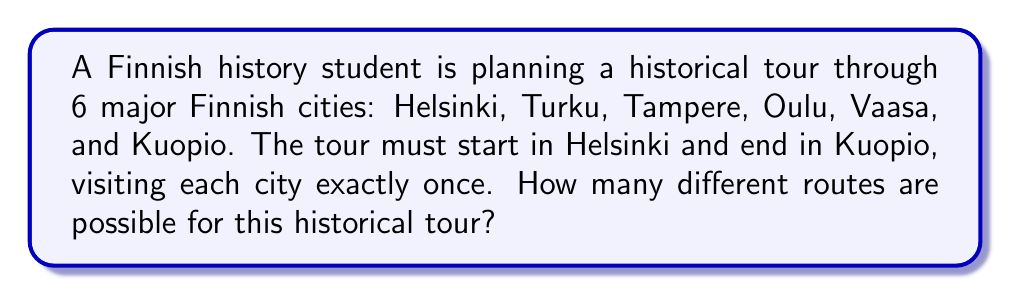What is the answer to this math problem? Let's approach this step-by-step:

1) We start with Helsinki and end with Kuopio, so these cities are fixed in their positions.

2) We need to arrange the remaining 4 cities (Turku, Tampere, Oulu, and Vaasa) in between Helsinki and Kuopio.

3) This is a permutation problem. We are arranging 4 distinct cities, and the order matters.

4) The number of permutations of n distinct objects is given by the formula:

   $$P(n) = n!$$

   Where $n!$ represents the factorial of $n$.

5) In this case, $n = 4$, so we need to calculate $4!$:

   $$4! = 4 \times 3 \times 2 \times 1 = 24$$

6) Therefore, there are 24 different ways to arrange the 4 cities between Helsinki and Kuopio.

7) Each of these arrangements represents a unique route for the historical tour.

Thus, there are 24 possible routes for the Finnish history student's tour.
Answer: 24 